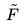<formula> <loc_0><loc_0><loc_500><loc_500>\tilde { F }</formula> 